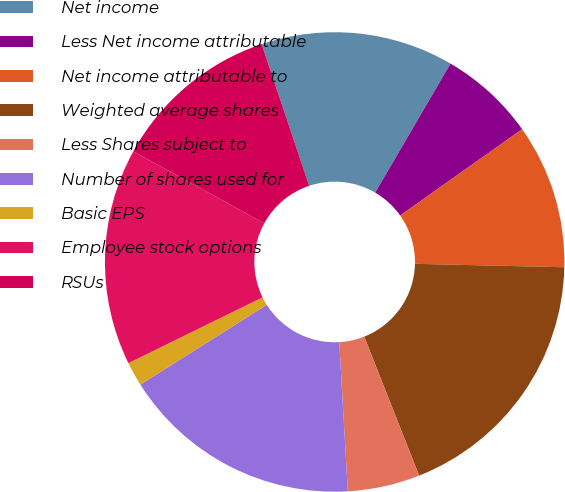<chart> <loc_0><loc_0><loc_500><loc_500><pie_chart><fcel>Net income<fcel>Less Net income attributable<fcel>Net income attributable to<fcel>Weighted average shares<fcel>Less Shares subject to<fcel>Number of shares used for<fcel>Basic EPS<fcel>Employee stock options<fcel>RSUs<nl><fcel>13.56%<fcel>6.78%<fcel>10.17%<fcel>18.64%<fcel>5.08%<fcel>16.95%<fcel>1.7%<fcel>15.25%<fcel>11.86%<nl></chart> 